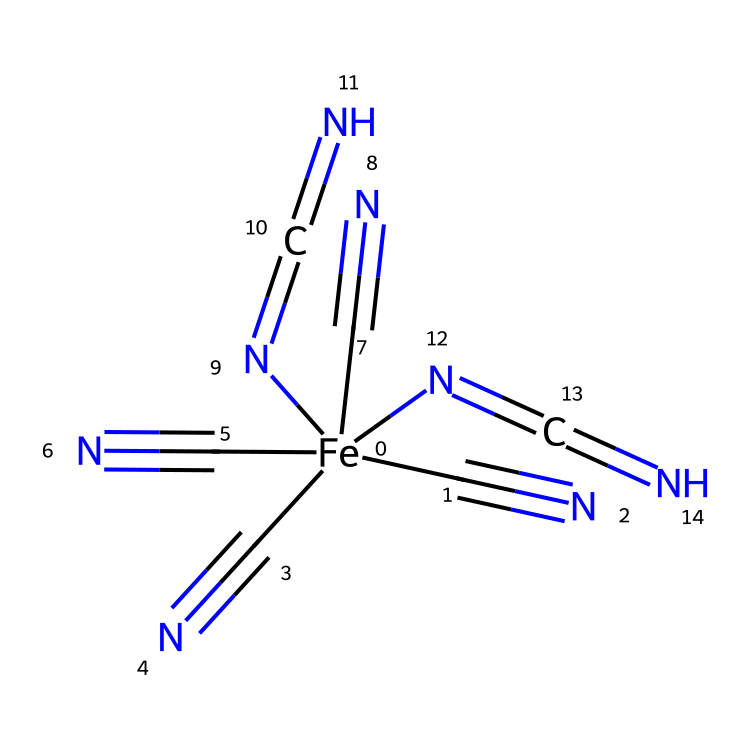What is the central metal atom in this compound? The chemical structure prominently features iron (Fe), which is located at the center of the SMILES representation.
Answer: iron How many cyanide (C#N) groups are present in this chemical? The SMILES shows four instances of the C#N group, indicating four cyanide ligands are attached to the iron atom.
Answer: four What is the total number of nitrogen atoms in the structure? The SMILES representation includes four nitrogen atoms from the cyanide ligands and two more from the azole-like components (N=C=N), totaling six nitrogen atoms.
Answer: six What type of bonding is illustrated in this chemical structure? The structure includes both coordinate covalent bonds (from the cyanides) and possible double bonds (from N=C), typical in organometallic chemistry.
Answer: coordinate and double What makes this compound a suitable catalyst for CO2 reduction? The iron's coordination with multiple strong field ligands such as cyanides and the unique bonding arrangement may provide a favorable electronic environment for the reduction of CO2.
Answer: iron coordination How does the presence of multiple nitrogen atoms impact the reactivity of the iron center? The presence of multiple nitrogen atoms can enhance the electron density around the iron center, affecting its reactivity and catalytic behavior due to increased nucleophilicity.
Answer: enhances reactivity What type of organometallic compound is represented by this SMILES string? This structure can be classified as a coordination complex due to the presence of metal-ligand coordinates formed with cyano groups and complex nitrogen ligand interactions.
Answer: coordination complex 